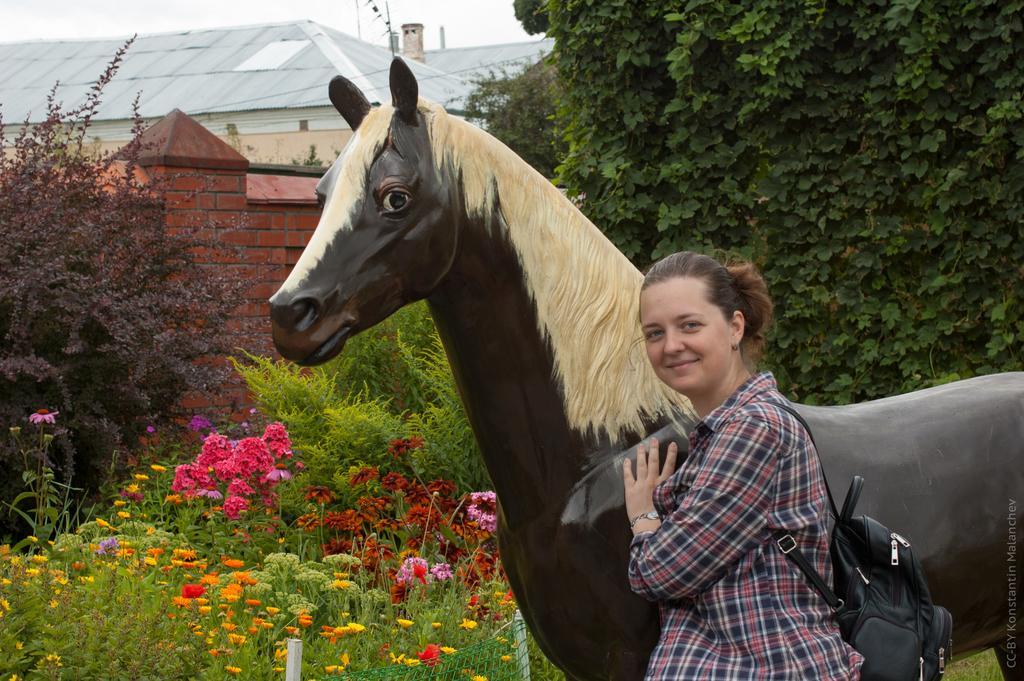Please provide a concise description of this image. In this image I can see a woman standing near the artificial horse. In the background, I can see the flowers and trees. 